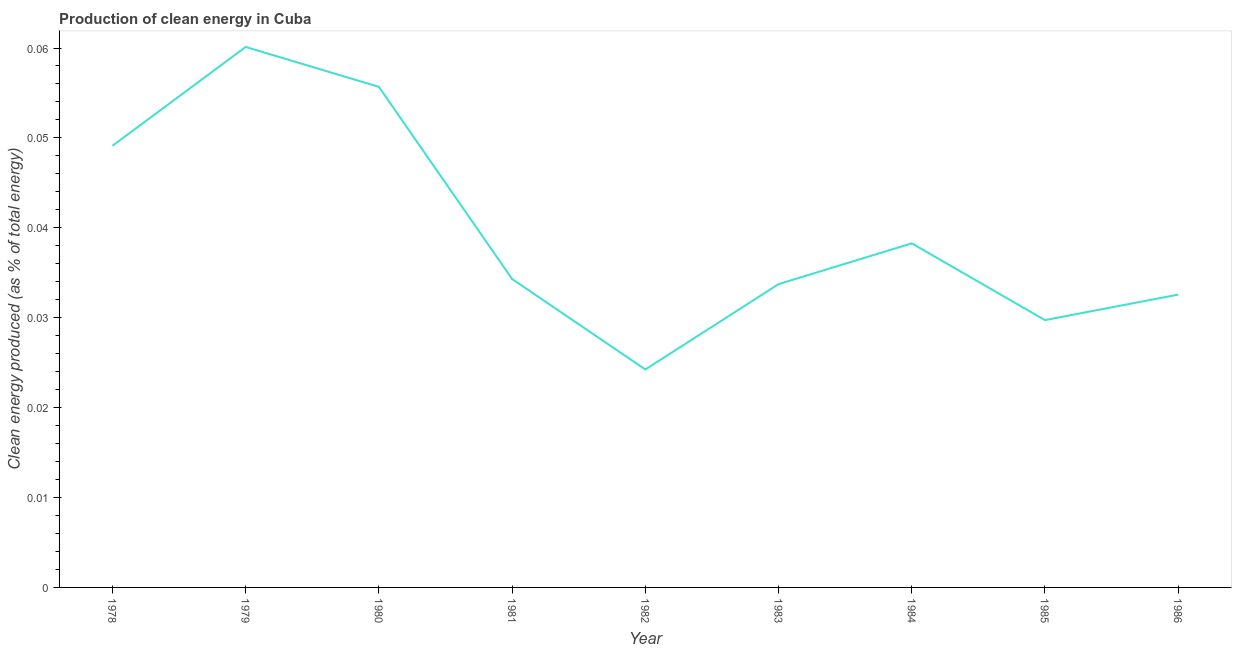What is the production of clean energy in 1978?
Offer a terse response. 0.05. Across all years, what is the maximum production of clean energy?
Make the answer very short. 0.06. Across all years, what is the minimum production of clean energy?
Offer a very short reply. 0.02. In which year was the production of clean energy maximum?
Offer a terse response. 1979. What is the sum of the production of clean energy?
Your answer should be very brief. 0.36. What is the difference between the production of clean energy in 1982 and 1985?
Ensure brevity in your answer.  -0.01. What is the average production of clean energy per year?
Offer a terse response. 0.04. What is the median production of clean energy?
Make the answer very short. 0.03. What is the ratio of the production of clean energy in 1980 to that in 1985?
Keep it short and to the point. 1.87. Is the production of clean energy in 1981 less than that in 1984?
Your answer should be compact. Yes. What is the difference between the highest and the second highest production of clean energy?
Provide a succinct answer. 0. What is the difference between the highest and the lowest production of clean energy?
Ensure brevity in your answer.  0.04. In how many years, is the production of clean energy greater than the average production of clean energy taken over all years?
Offer a very short reply. 3. Does the production of clean energy monotonically increase over the years?
Keep it short and to the point. No. How many lines are there?
Your response must be concise. 1. What is the difference between two consecutive major ticks on the Y-axis?
Make the answer very short. 0.01. Does the graph contain grids?
Provide a short and direct response. No. What is the title of the graph?
Your response must be concise. Production of clean energy in Cuba. What is the label or title of the X-axis?
Make the answer very short. Year. What is the label or title of the Y-axis?
Ensure brevity in your answer.  Clean energy produced (as % of total energy). What is the Clean energy produced (as % of total energy) of 1978?
Ensure brevity in your answer.  0.05. What is the Clean energy produced (as % of total energy) in 1979?
Make the answer very short. 0.06. What is the Clean energy produced (as % of total energy) of 1980?
Offer a terse response. 0.06. What is the Clean energy produced (as % of total energy) of 1981?
Provide a short and direct response. 0.03. What is the Clean energy produced (as % of total energy) of 1982?
Offer a very short reply. 0.02. What is the Clean energy produced (as % of total energy) of 1983?
Offer a terse response. 0.03. What is the Clean energy produced (as % of total energy) in 1984?
Provide a succinct answer. 0.04. What is the Clean energy produced (as % of total energy) in 1985?
Provide a short and direct response. 0.03. What is the Clean energy produced (as % of total energy) of 1986?
Give a very brief answer. 0.03. What is the difference between the Clean energy produced (as % of total energy) in 1978 and 1979?
Keep it short and to the point. -0.01. What is the difference between the Clean energy produced (as % of total energy) in 1978 and 1980?
Offer a very short reply. -0.01. What is the difference between the Clean energy produced (as % of total energy) in 1978 and 1981?
Give a very brief answer. 0.01. What is the difference between the Clean energy produced (as % of total energy) in 1978 and 1982?
Your response must be concise. 0.02. What is the difference between the Clean energy produced (as % of total energy) in 1978 and 1983?
Offer a terse response. 0.02. What is the difference between the Clean energy produced (as % of total energy) in 1978 and 1984?
Offer a very short reply. 0.01. What is the difference between the Clean energy produced (as % of total energy) in 1978 and 1985?
Provide a succinct answer. 0.02. What is the difference between the Clean energy produced (as % of total energy) in 1978 and 1986?
Your answer should be compact. 0.02. What is the difference between the Clean energy produced (as % of total energy) in 1979 and 1980?
Provide a short and direct response. 0. What is the difference between the Clean energy produced (as % of total energy) in 1979 and 1981?
Your response must be concise. 0.03. What is the difference between the Clean energy produced (as % of total energy) in 1979 and 1982?
Your answer should be very brief. 0.04. What is the difference between the Clean energy produced (as % of total energy) in 1979 and 1983?
Your answer should be compact. 0.03. What is the difference between the Clean energy produced (as % of total energy) in 1979 and 1984?
Your answer should be very brief. 0.02. What is the difference between the Clean energy produced (as % of total energy) in 1979 and 1985?
Your answer should be compact. 0.03. What is the difference between the Clean energy produced (as % of total energy) in 1979 and 1986?
Offer a very short reply. 0.03. What is the difference between the Clean energy produced (as % of total energy) in 1980 and 1981?
Provide a succinct answer. 0.02. What is the difference between the Clean energy produced (as % of total energy) in 1980 and 1982?
Keep it short and to the point. 0.03. What is the difference between the Clean energy produced (as % of total energy) in 1980 and 1983?
Offer a terse response. 0.02. What is the difference between the Clean energy produced (as % of total energy) in 1980 and 1984?
Your answer should be very brief. 0.02. What is the difference between the Clean energy produced (as % of total energy) in 1980 and 1985?
Provide a succinct answer. 0.03. What is the difference between the Clean energy produced (as % of total energy) in 1980 and 1986?
Offer a very short reply. 0.02. What is the difference between the Clean energy produced (as % of total energy) in 1981 and 1982?
Offer a very short reply. 0.01. What is the difference between the Clean energy produced (as % of total energy) in 1981 and 1983?
Your answer should be compact. 0. What is the difference between the Clean energy produced (as % of total energy) in 1981 and 1984?
Your answer should be compact. -0. What is the difference between the Clean energy produced (as % of total energy) in 1981 and 1985?
Give a very brief answer. 0. What is the difference between the Clean energy produced (as % of total energy) in 1981 and 1986?
Offer a terse response. 0. What is the difference between the Clean energy produced (as % of total energy) in 1982 and 1983?
Offer a very short reply. -0.01. What is the difference between the Clean energy produced (as % of total energy) in 1982 and 1984?
Your response must be concise. -0.01. What is the difference between the Clean energy produced (as % of total energy) in 1982 and 1985?
Your answer should be very brief. -0.01. What is the difference between the Clean energy produced (as % of total energy) in 1982 and 1986?
Your response must be concise. -0.01. What is the difference between the Clean energy produced (as % of total energy) in 1983 and 1984?
Keep it short and to the point. -0. What is the difference between the Clean energy produced (as % of total energy) in 1983 and 1985?
Provide a succinct answer. 0. What is the difference between the Clean energy produced (as % of total energy) in 1983 and 1986?
Give a very brief answer. 0. What is the difference between the Clean energy produced (as % of total energy) in 1984 and 1985?
Give a very brief answer. 0.01. What is the difference between the Clean energy produced (as % of total energy) in 1984 and 1986?
Offer a terse response. 0.01. What is the difference between the Clean energy produced (as % of total energy) in 1985 and 1986?
Provide a short and direct response. -0. What is the ratio of the Clean energy produced (as % of total energy) in 1978 to that in 1979?
Provide a short and direct response. 0.82. What is the ratio of the Clean energy produced (as % of total energy) in 1978 to that in 1980?
Provide a succinct answer. 0.88. What is the ratio of the Clean energy produced (as % of total energy) in 1978 to that in 1981?
Give a very brief answer. 1.43. What is the ratio of the Clean energy produced (as % of total energy) in 1978 to that in 1982?
Provide a succinct answer. 2.03. What is the ratio of the Clean energy produced (as % of total energy) in 1978 to that in 1983?
Provide a short and direct response. 1.46. What is the ratio of the Clean energy produced (as % of total energy) in 1978 to that in 1984?
Keep it short and to the point. 1.28. What is the ratio of the Clean energy produced (as % of total energy) in 1978 to that in 1985?
Make the answer very short. 1.65. What is the ratio of the Clean energy produced (as % of total energy) in 1978 to that in 1986?
Your response must be concise. 1.51. What is the ratio of the Clean energy produced (as % of total energy) in 1979 to that in 1980?
Give a very brief answer. 1.08. What is the ratio of the Clean energy produced (as % of total energy) in 1979 to that in 1981?
Your answer should be very brief. 1.75. What is the ratio of the Clean energy produced (as % of total energy) in 1979 to that in 1982?
Provide a succinct answer. 2.48. What is the ratio of the Clean energy produced (as % of total energy) in 1979 to that in 1983?
Provide a succinct answer. 1.78. What is the ratio of the Clean energy produced (as % of total energy) in 1979 to that in 1984?
Your answer should be compact. 1.57. What is the ratio of the Clean energy produced (as % of total energy) in 1979 to that in 1985?
Make the answer very short. 2.02. What is the ratio of the Clean energy produced (as % of total energy) in 1979 to that in 1986?
Your answer should be very brief. 1.85. What is the ratio of the Clean energy produced (as % of total energy) in 1980 to that in 1981?
Your response must be concise. 1.62. What is the ratio of the Clean energy produced (as % of total energy) in 1980 to that in 1982?
Your answer should be compact. 2.3. What is the ratio of the Clean energy produced (as % of total energy) in 1980 to that in 1983?
Provide a succinct answer. 1.65. What is the ratio of the Clean energy produced (as % of total energy) in 1980 to that in 1984?
Make the answer very short. 1.46. What is the ratio of the Clean energy produced (as % of total energy) in 1980 to that in 1985?
Ensure brevity in your answer.  1.87. What is the ratio of the Clean energy produced (as % of total energy) in 1980 to that in 1986?
Make the answer very short. 1.71. What is the ratio of the Clean energy produced (as % of total energy) in 1981 to that in 1982?
Your answer should be very brief. 1.42. What is the ratio of the Clean energy produced (as % of total energy) in 1981 to that in 1983?
Keep it short and to the point. 1.02. What is the ratio of the Clean energy produced (as % of total energy) in 1981 to that in 1984?
Ensure brevity in your answer.  0.9. What is the ratio of the Clean energy produced (as % of total energy) in 1981 to that in 1985?
Offer a very short reply. 1.15. What is the ratio of the Clean energy produced (as % of total energy) in 1981 to that in 1986?
Your answer should be compact. 1.05. What is the ratio of the Clean energy produced (as % of total energy) in 1982 to that in 1983?
Your answer should be very brief. 0.72. What is the ratio of the Clean energy produced (as % of total energy) in 1982 to that in 1984?
Keep it short and to the point. 0.63. What is the ratio of the Clean energy produced (as % of total energy) in 1982 to that in 1985?
Give a very brief answer. 0.81. What is the ratio of the Clean energy produced (as % of total energy) in 1982 to that in 1986?
Offer a very short reply. 0.74. What is the ratio of the Clean energy produced (as % of total energy) in 1983 to that in 1984?
Make the answer very short. 0.88. What is the ratio of the Clean energy produced (as % of total energy) in 1983 to that in 1985?
Ensure brevity in your answer.  1.14. What is the ratio of the Clean energy produced (as % of total energy) in 1983 to that in 1986?
Provide a short and direct response. 1.04. What is the ratio of the Clean energy produced (as % of total energy) in 1984 to that in 1985?
Keep it short and to the point. 1.29. What is the ratio of the Clean energy produced (as % of total energy) in 1984 to that in 1986?
Provide a short and direct response. 1.18. What is the ratio of the Clean energy produced (as % of total energy) in 1985 to that in 1986?
Your answer should be very brief. 0.91. 